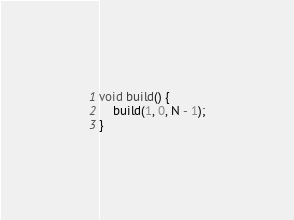<code> <loc_0><loc_0><loc_500><loc_500><_Java_>void build() {
    build(1, 0, N - 1);
}</code> 